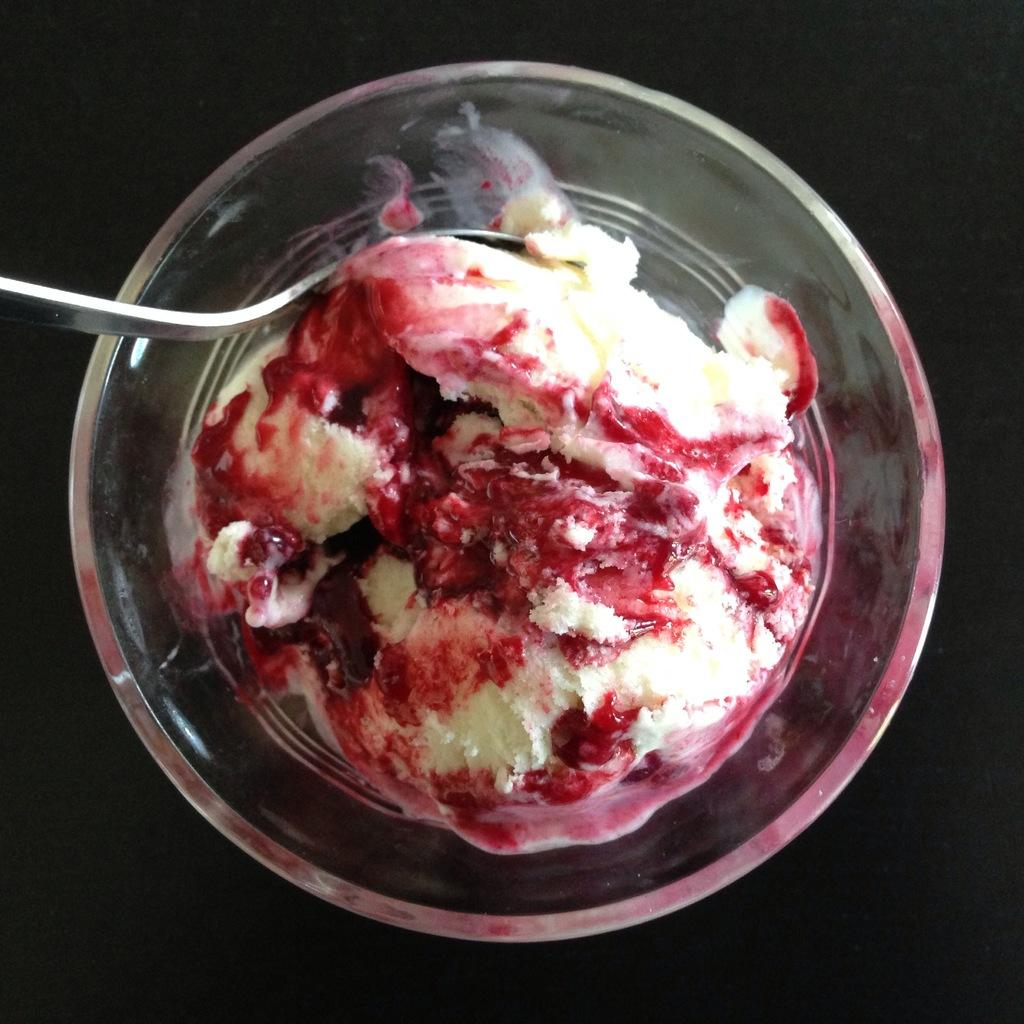What is the main subject of the image? The main subject of the image is an ice cream. How is the ice cream presented in the image? The ice cream is placed in a bowl. What utensil is visible in the image? There is a spoon in the image. Can you see any cobwebs in the image? There are no cobwebs present in the image. What type of paper is being used to wrap the ice cream in the image? There is no paper visible in the image; the ice cream is placed in a bowl. 